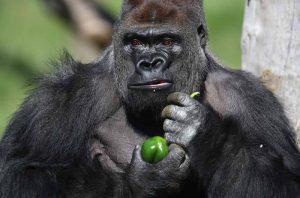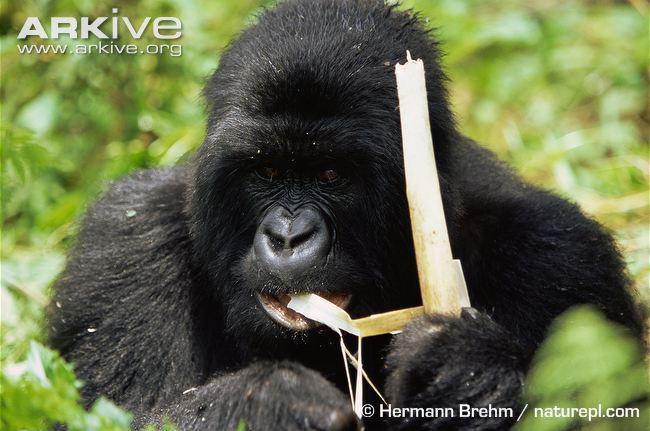The first image is the image on the left, the second image is the image on the right. Evaluate the accuracy of this statement regarding the images: "One of the photos contains more than one animal.". Is it true? Answer yes or no. No. The first image is the image on the left, the second image is the image on the right. Analyze the images presented: Is the assertion "The gorilla in the right image is chewing on a fibrous stalk." valid? Answer yes or no. Yes. 